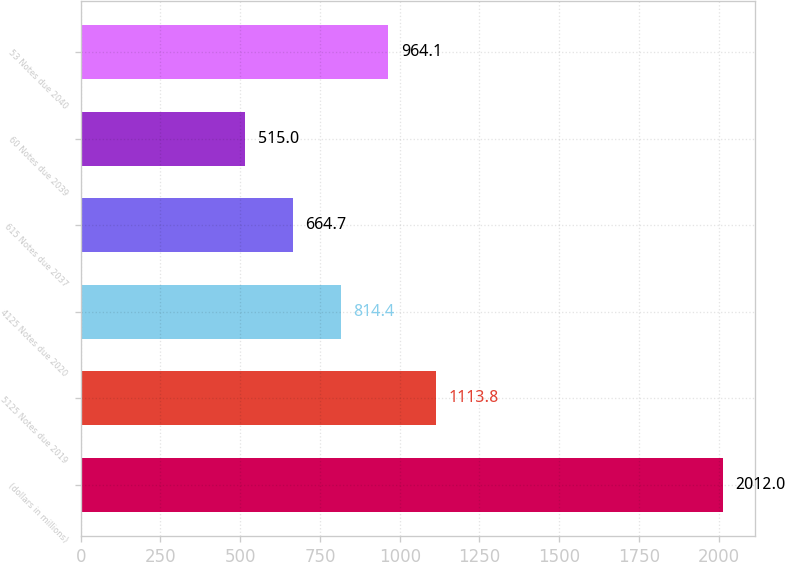Convert chart. <chart><loc_0><loc_0><loc_500><loc_500><bar_chart><fcel>(dollars in millions)<fcel>5125 Notes due 2019<fcel>4125 Notes due 2020<fcel>615 Notes due 2037<fcel>60 Notes due 2039<fcel>53 Notes due 2040<nl><fcel>2012<fcel>1113.8<fcel>814.4<fcel>664.7<fcel>515<fcel>964.1<nl></chart> 